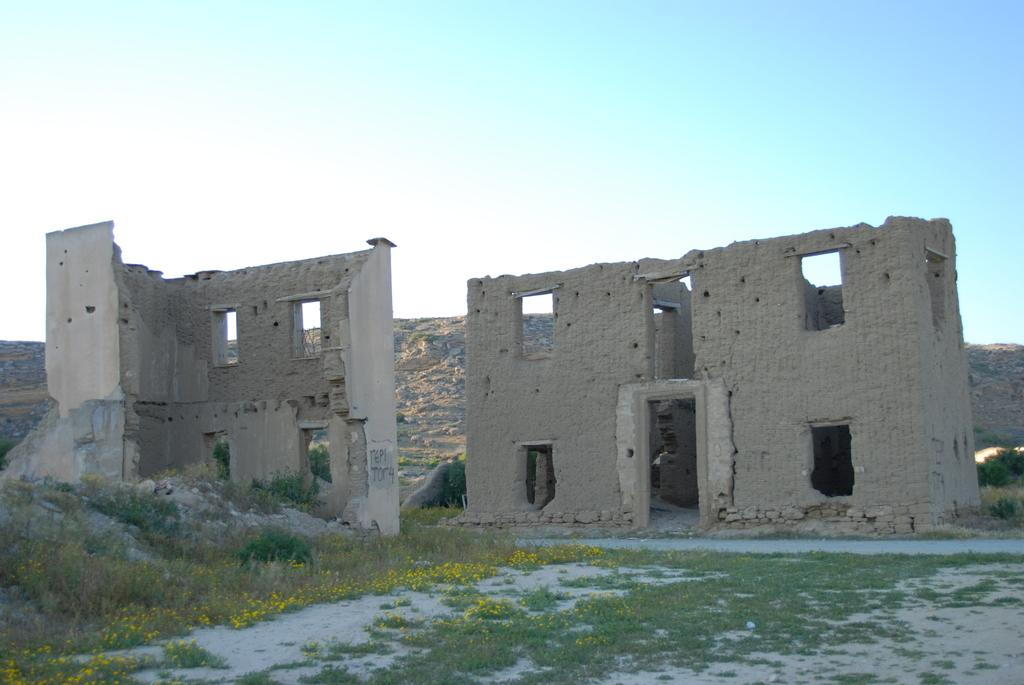How many buildings can be seen in the image? There are two buildings in the image. What else is present on the ground besides the buildings? There are plants with flowers on the ground. What can be seen in the background of the image? There is a hill and the sky visible in the background. Can you describe the behavior of the monkey in the image? There is no monkey present in the image. How does the beast interact with the plants in the image? There is no beast present in the image, so it cannot interact with the plants. 